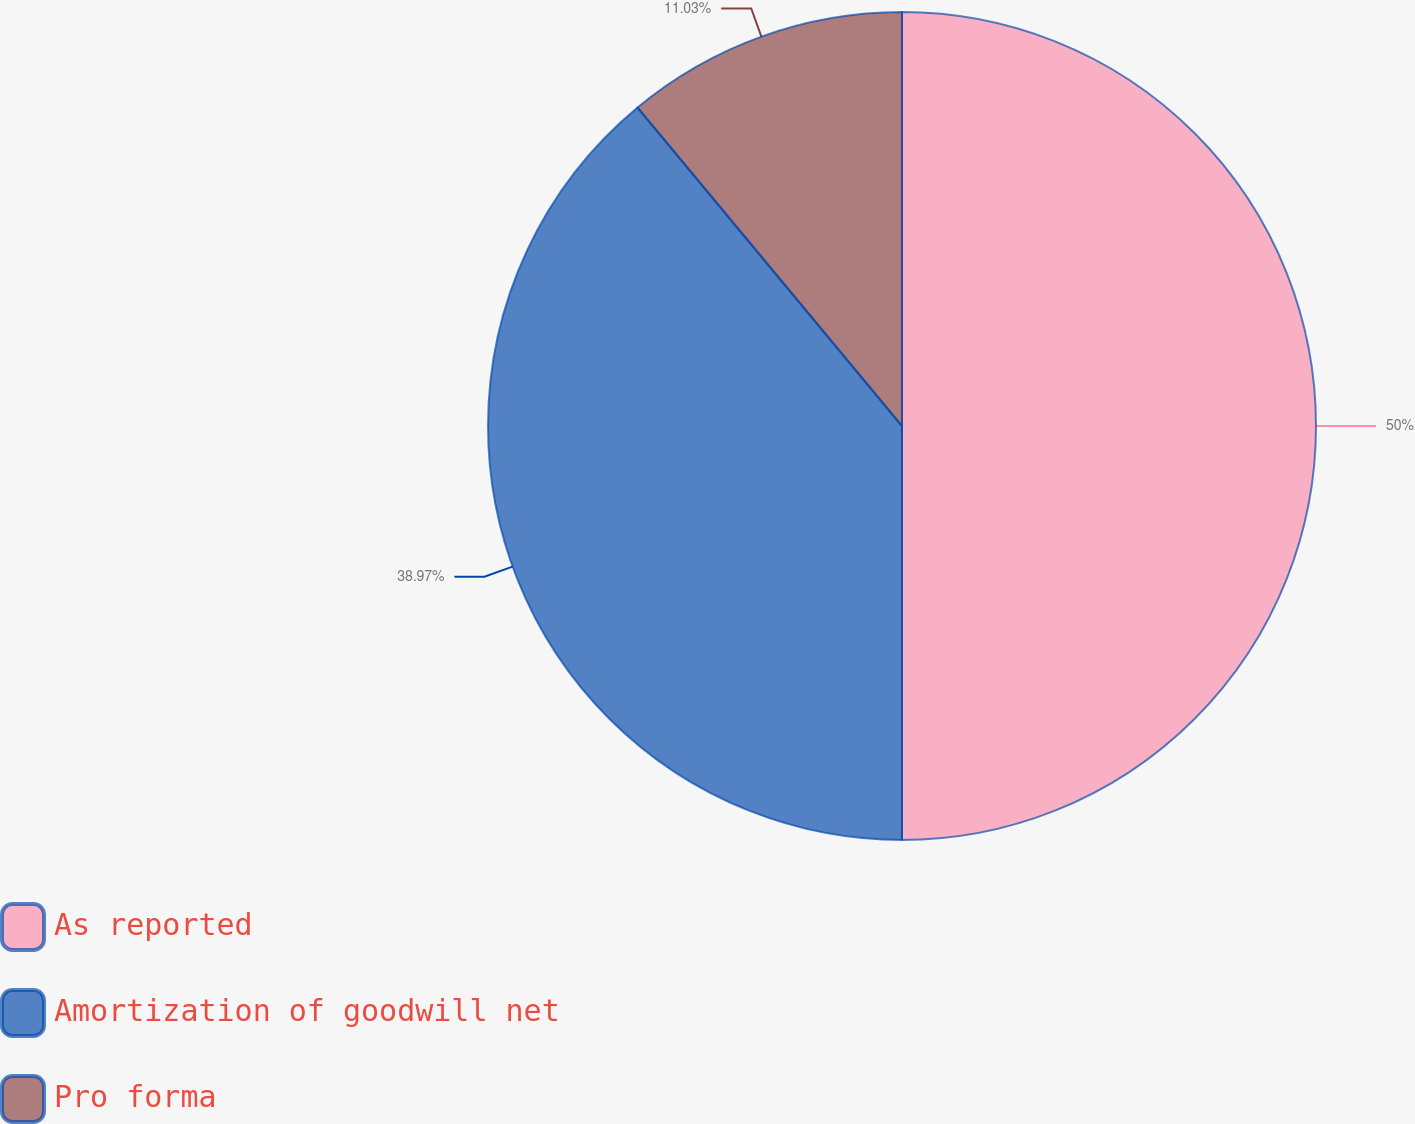Convert chart. <chart><loc_0><loc_0><loc_500><loc_500><pie_chart><fcel>As reported<fcel>Amortization of goodwill net<fcel>Pro forma<nl><fcel>50.0%<fcel>38.97%<fcel>11.03%<nl></chart> 